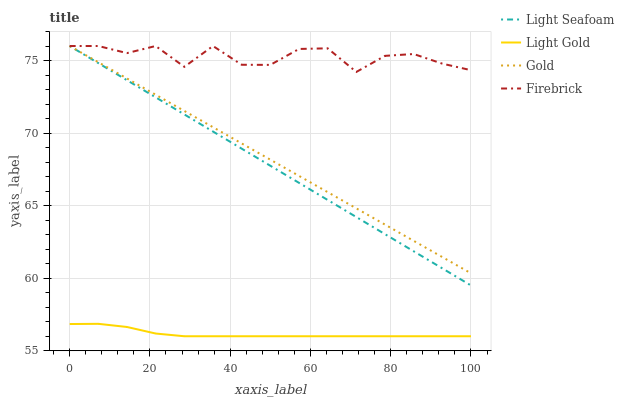Does Light Gold have the minimum area under the curve?
Answer yes or no. Yes. Does Firebrick have the maximum area under the curve?
Answer yes or no. Yes. Does Light Seafoam have the minimum area under the curve?
Answer yes or no. No. Does Light Seafoam have the maximum area under the curve?
Answer yes or no. No. Is Light Seafoam the smoothest?
Answer yes or no. Yes. Is Firebrick the roughest?
Answer yes or no. Yes. Is Light Gold the smoothest?
Answer yes or no. No. Is Light Gold the roughest?
Answer yes or no. No. Does Light Gold have the lowest value?
Answer yes or no. Yes. Does Light Seafoam have the lowest value?
Answer yes or no. No. Does Gold have the highest value?
Answer yes or no. Yes. Does Light Gold have the highest value?
Answer yes or no. No. Is Light Gold less than Gold?
Answer yes or no. Yes. Is Light Seafoam greater than Light Gold?
Answer yes or no. Yes. Does Firebrick intersect Gold?
Answer yes or no. Yes. Is Firebrick less than Gold?
Answer yes or no. No. Is Firebrick greater than Gold?
Answer yes or no. No. Does Light Gold intersect Gold?
Answer yes or no. No. 